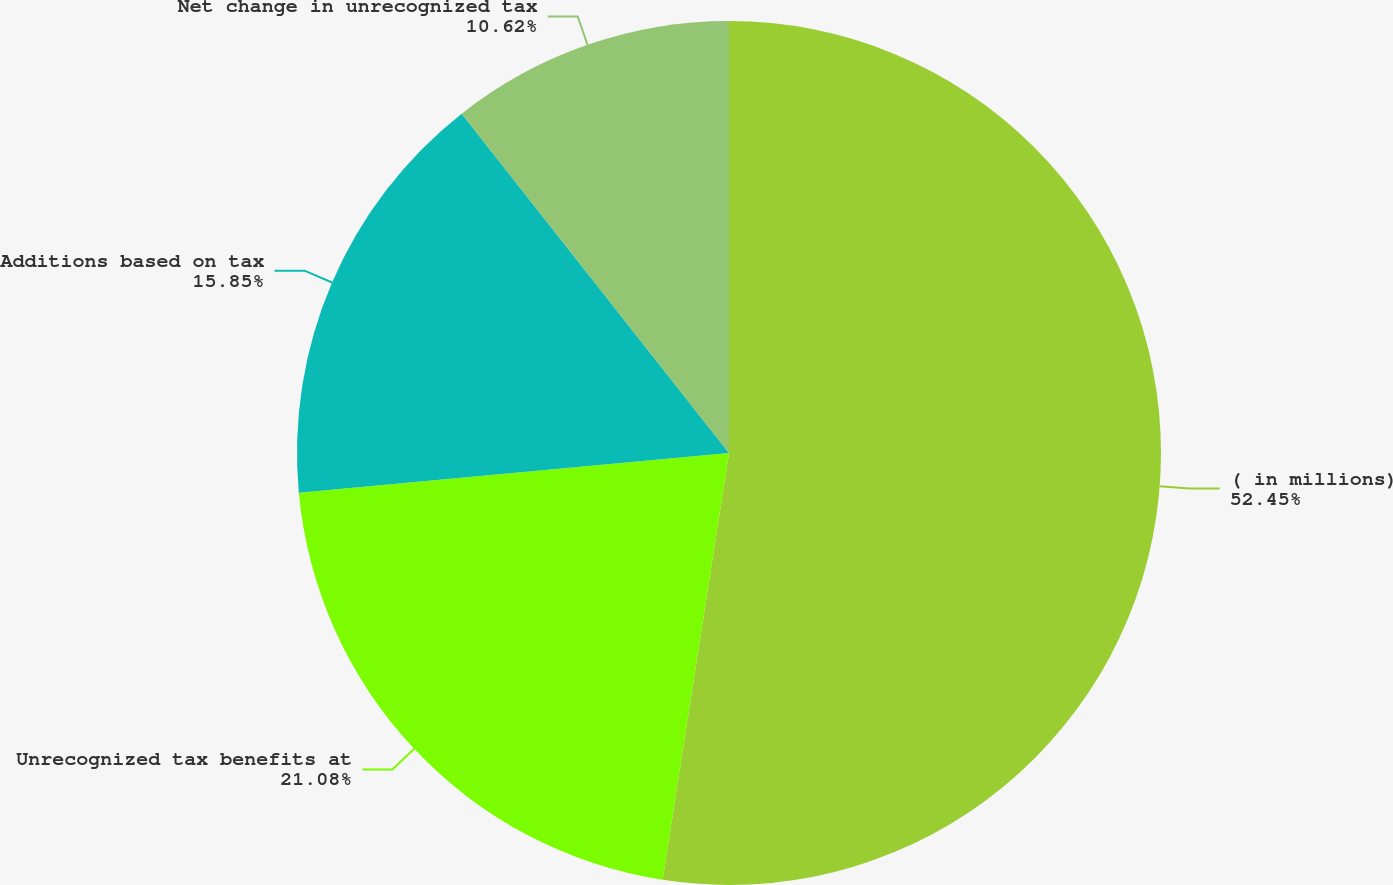<chart> <loc_0><loc_0><loc_500><loc_500><pie_chart><fcel>( in millions)<fcel>Unrecognized tax benefits at<fcel>Additions based on tax<fcel>Net change in unrecognized tax<nl><fcel>52.46%<fcel>21.08%<fcel>15.85%<fcel>10.62%<nl></chart> 